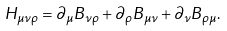Convert formula to latex. <formula><loc_0><loc_0><loc_500><loc_500>H _ { \mu \nu \rho } = \partial _ { \mu } B _ { \nu \rho } + \partial _ { \rho } B _ { \mu \nu } + \partial _ { \nu } B _ { \rho \mu } .</formula> 